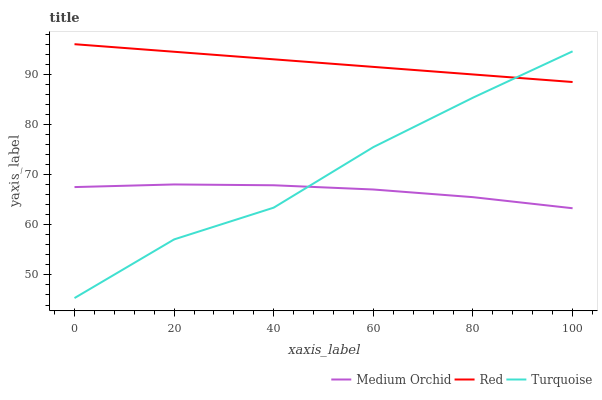Does Red have the minimum area under the curve?
Answer yes or no. No. Does Medium Orchid have the maximum area under the curve?
Answer yes or no. No. Is Medium Orchid the smoothest?
Answer yes or no. No. Is Medium Orchid the roughest?
Answer yes or no. No. Does Medium Orchid have the lowest value?
Answer yes or no. No. Does Medium Orchid have the highest value?
Answer yes or no. No. Is Medium Orchid less than Red?
Answer yes or no. Yes. Is Red greater than Medium Orchid?
Answer yes or no. Yes. Does Medium Orchid intersect Red?
Answer yes or no. No. 